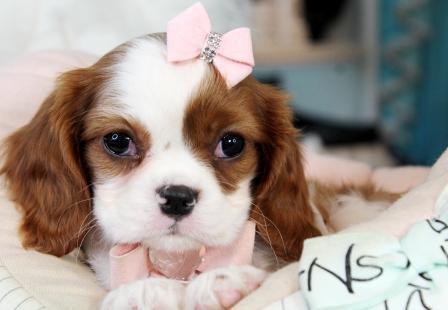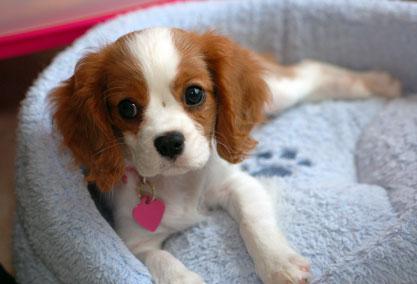The first image is the image on the left, the second image is the image on the right. For the images shown, is this caption "There is exactly three dogs in the right image." true? Answer yes or no. No. The first image is the image on the left, the second image is the image on the right. Considering the images on both sides, is "There are three dogs in one image and two in another." valid? Answer yes or no. No. 